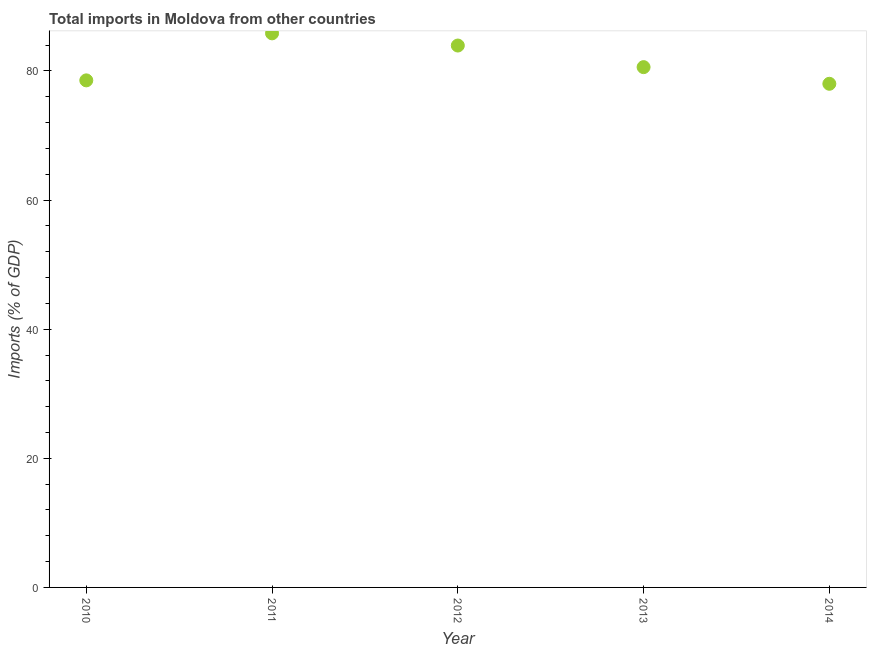What is the total imports in 2012?
Offer a terse response. 83.94. Across all years, what is the maximum total imports?
Offer a terse response. 85.83. Across all years, what is the minimum total imports?
Ensure brevity in your answer.  78.02. What is the sum of the total imports?
Ensure brevity in your answer.  406.93. What is the difference between the total imports in 2010 and 2014?
Make the answer very short. 0.53. What is the average total imports per year?
Make the answer very short. 81.39. What is the median total imports?
Give a very brief answer. 80.6. In how many years, is the total imports greater than 12 %?
Make the answer very short. 5. Do a majority of the years between 2010 and 2014 (inclusive) have total imports greater than 4 %?
Give a very brief answer. Yes. What is the ratio of the total imports in 2012 to that in 2013?
Ensure brevity in your answer.  1.04. Is the total imports in 2011 less than that in 2012?
Your answer should be compact. No. What is the difference between the highest and the second highest total imports?
Offer a very short reply. 1.89. What is the difference between the highest and the lowest total imports?
Provide a succinct answer. 7.81. What is the difference between two consecutive major ticks on the Y-axis?
Ensure brevity in your answer.  20. Does the graph contain any zero values?
Keep it short and to the point. No. What is the title of the graph?
Your answer should be very brief. Total imports in Moldova from other countries. What is the label or title of the X-axis?
Give a very brief answer. Year. What is the label or title of the Y-axis?
Provide a short and direct response. Imports (% of GDP). What is the Imports (% of GDP) in 2010?
Make the answer very short. 78.55. What is the Imports (% of GDP) in 2011?
Your response must be concise. 85.83. What is the Imports (% of GDP) in 2012?
Provide a short and direct response. 83.94. What is the Imports (% of GDP) in 2013?
Ensure brevity in your answer.  80.6. What is the Imports (% of GDP) in 2014?
Your answer should be compact. 78.02. What is the difference between the Imports (% of GDP) in 2010 and 2011?
Offer a very short reply. -7.28. What is the difference between the Imports (% of GDP) in 2010 and 2012?
Give a very brief answer. -5.4. What is the difference between the Imports (% of GDP) in 2010 and 2013?
Keep it short and to the point. -2.05. What is the difference between the Imports (% of GDP) in 2010 and 2014?
Give a very brief answer. 0.53. What is the difference between the Imports (% of GDP) in 2011 and 2012?
Provide a short and direct response. 1.89. What is the difference between the Imports (% of GDP) in 2011 and 2013?
Offer a very short reply. 5.23. What is the difference between the Imports (% of GDP) in 2011 and 2014?
Your response must be concise. 7.81. What is the difference between the Imports (% of GDP) in 2012 and 2013?
Offer a very short reply. 3.35. What is the difference between the Imports (% of GDP) in 2012 and 2014?
Give a very brief answer. 5.93. What is the difference between the Imports (% of GDP) in 2013 and 2014?
Your response must be concise. 2.58. What is the ratio of the Imports (% of GDP) in 2010 to that in 2011?
Your response must be concise. 0.92. What is the ratio of the Imports (% of GDP) in 2010 to that in 2012?
Ensure brevity in your answer.  0.94. What is the ratio of the Imports (% of GDP) in 2010 to that in 2014?
Offer a terse response. 1.01. What is the ratio of the Imports (% of GDP) in 2011 to that in 2013?
Ensure brevity in your answer.  1.06. What is the ratio of the Imports (% of GDP) in 2011 to that in 2014?
Provide a succinct answer. 1.1. What is the ratio of the Imports (% of GDP) in 2012 to that in 2013?
Your response must be concise. 1.04. What is the ratio of the Imports (% of GDP) in 2012 to that in 2014?
Your answer should be very brief. 1.08. What is the ratio of the Imports (% of GDP) in 2013 to that in 2014?
Your response must be concise. 1.03. 